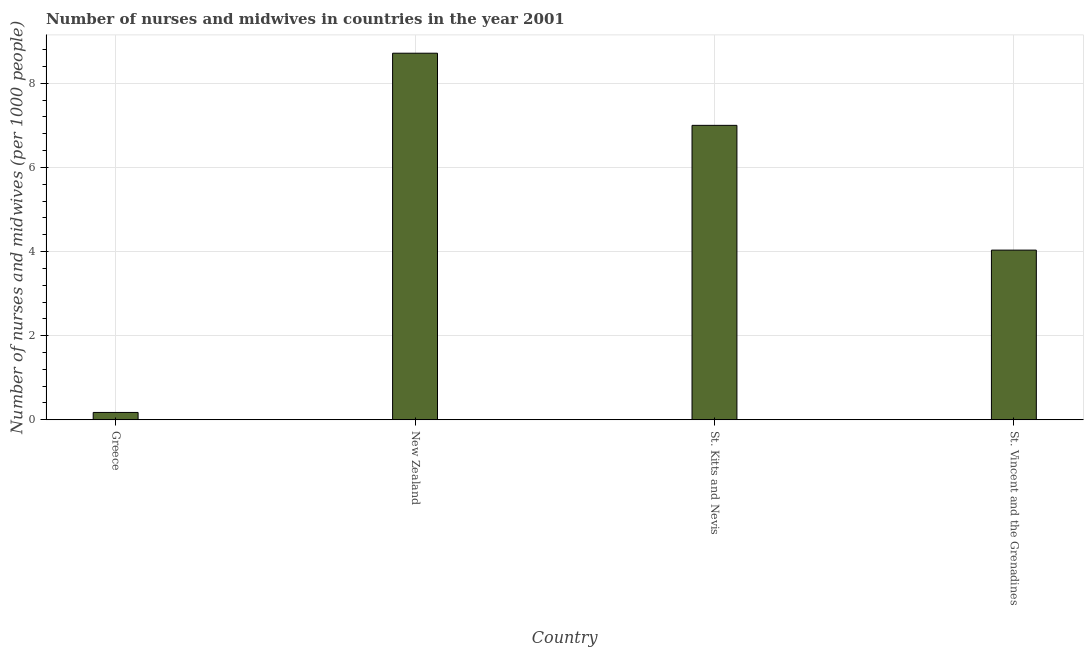What is the title of the graph?
Your answer should be compact. Number of nurses and midwives in countries in the year 2001. What is the label or title of the X-axis?
Offer a very short reply. Country. What is the label or title of the Y-axis?
Provide a short and direct response. Number of nurses and midwives (per 1000 people). What is the number of nurses and midwives in St. Vincent and the Grenadines?
Provide a short and direct response. 4.03. Across all countries, what is the maximum number of nurses and midwives?
Keep it short and to the point. 8.71. Across all countries, what is the minimum number of nurses and midwives?
Give a very brief answer. 0.17. In which country was the number of nurses and midwives maximum?
Your answer should be compact. New Zealand. What is the sum of the number of nurses and midwives?
Your response must be concise. 19.92. What is the difference between the number of nurses and midwives in New Zealand and St. Vincent and the Grenadines?
Provide a succinct answer. 4.68. What is the average number of nurses and midwives per country?
Provide a short and direct response. 4.98. What is the median number of nurses and midwives?
Provide a short and direct response. 5.52. What is the ratio of the number of nurses and midwives in Greece to that in St. Kitts and Nevis?
Provide a succinct answer. 0.03. Is the number of nurses and midwives in St. Kitts and Nevis less than that in St. Vincent and the Grenadines?
Your answer should be compact. No. What is the difference between the highest and the second highest number of nurses and midwives?
Give a very brief answer. 1.72. What is the difference between the highest and the lowest number of nurses and midwives?
Give a very brief answer. 8.54. In how many countries, is the number of nurses and midwives greater than the average number of nurses and midwives taken over all countries?
Ensure brevity in your answer.  2. How many bars are there?
Keep it short and to the point. 4. Are all the bars in the graph horizontal?
Keep it short and to the point. No. How many countries are there in the graph?
Provide a succinct answer. 4. Are the values on the major ticks of Y-axis written in scientific E-notation?
Keep it short and to the point. No. What is the Number of nurses and midwives (per 1000 people) of Greece?
Your answer should be very brief. 0.17. What is the Number of nurses and midwives (per 1000 people) of New Zealand?
Ensure brevity in your answer.  8.71. What is the Number of nurses and midwives (per 1000 people) in St. Vincent and the Grenadines?
Your answer should be very brief. 4.03. What is the difference between the Number of nurses and midwives (per 1000 people) in Greece and New Zealand?
Your answer should be compact. -8.54. What is the difference between the Number of nurses and midwives (per 1000 people) in Greece and St. Kitts and Nevis?
Your answer should be compact. -6.83. What is the difference between the Number of nurses and midwives (per 1000 people) in Greece and St. Vincent and the Grenadines?
Ensure brevity in your answer.  -3.86. What is the difference between the Number of nurses and midwives (per 1000 people) in New Zealand and St. Kitts and Nevis?
Provide a short and direct response. 1.72. What is the difference between the Number of nurses and midwives (per 1000 people) in New Zealand and St. Vincent and the Grenadines?
Offer a very short reply. 4.68. What is the difference between the Number of nurses and midwives (per 1000 people) in St. Kitts and Nevis and St. Vincent and the Grenadines?
Offer a terse response. 2.97. What is the ratio of the Number of nurses and midwives (per 1000 people) in Greece to that in St. Kitts and Nevis?
Keep it short and to the point. 0.03. What is the ratio of the Number of nurses and midwives (per 1000 people) in Greece to that in St. Vincent and the Grenadines?
Provide a succinct answer. 0.04. What is the ratio of the Number of nurses and midwives (per 1000 people) in New Zealand to that in St. Kitts and Nevis?
Your answer should be very brief. 1.25. What is the ratio of the Number of nurses and midwives (per 1000 people) in New Zealand to that in St. Vincent and the Grenadines?
Your answer should be compact. 2.16. What is the ratio of the Number of nurses and midwives (per 1000 people) in St. Kitts and Nevis to that in St. Vincent and the Grenadines?
Provide a short and direct response. 1.74. 